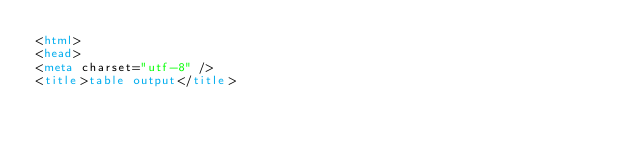Convert code to text. <code><loc_0><loc_0><loc_500><loc_500><_HTML_><html>
<head>
<meta charset="utf-8" />
<title>table output</title></code> 